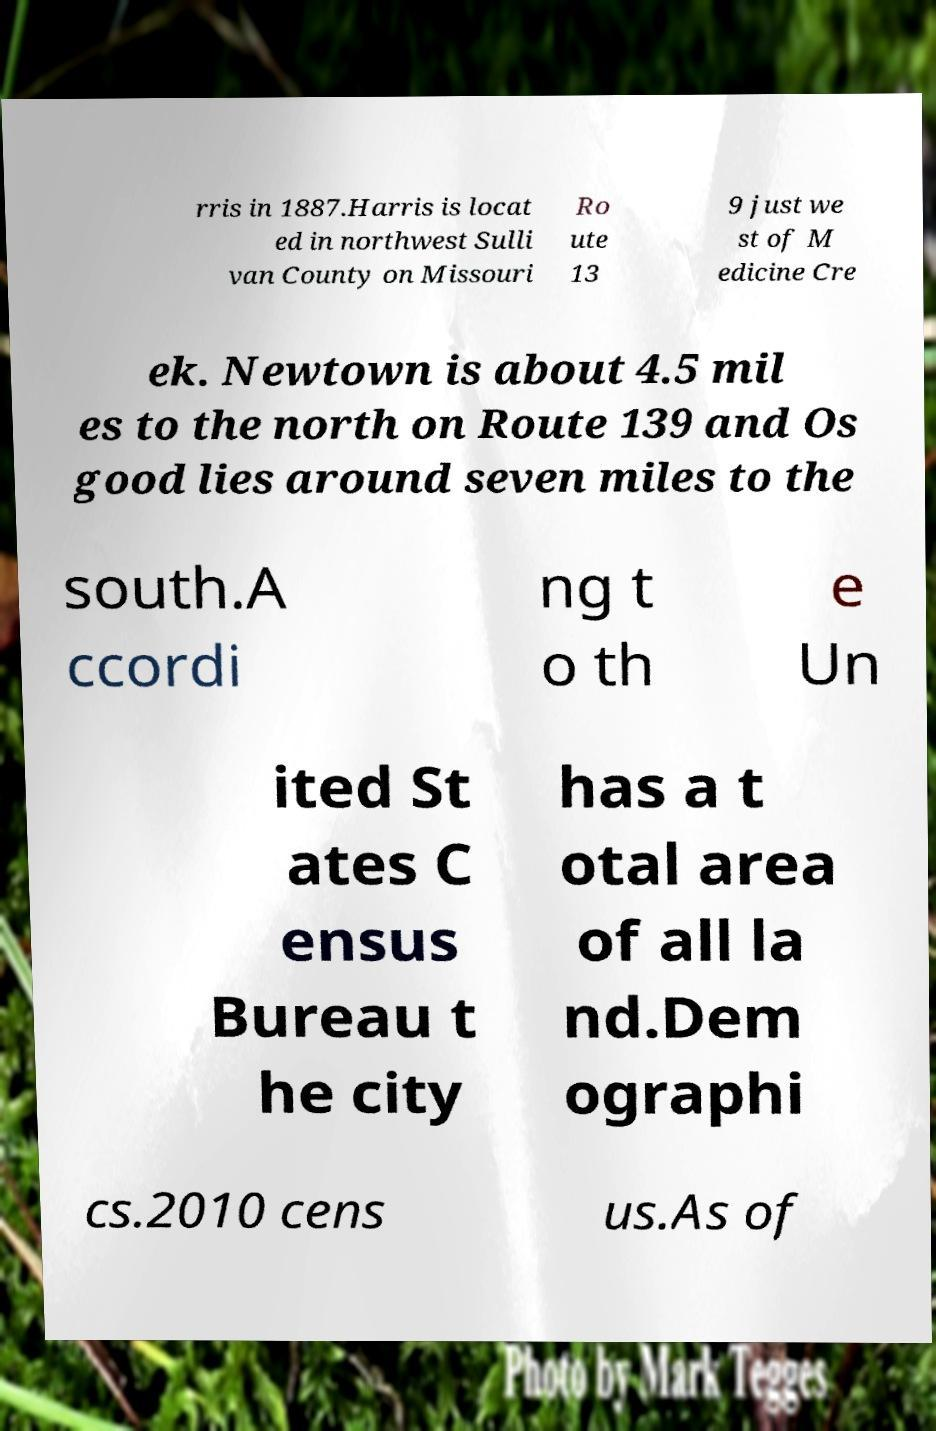Could you extract and type out the text from this image? rris in 1887.Harris is locat ed in northwest Sulli van County on Missouri Ro ute 13 9 just we st of M edicine Cre ek. Newtown is about 4.5 mil es to the north on Route 139 and Os good lies around seven miles to the south.A ccordi ng t o th e Un ited St ates C ensus Bureau t he city has a t otal area of all la nd.Dem ographi cs.2010 cens us.As of 